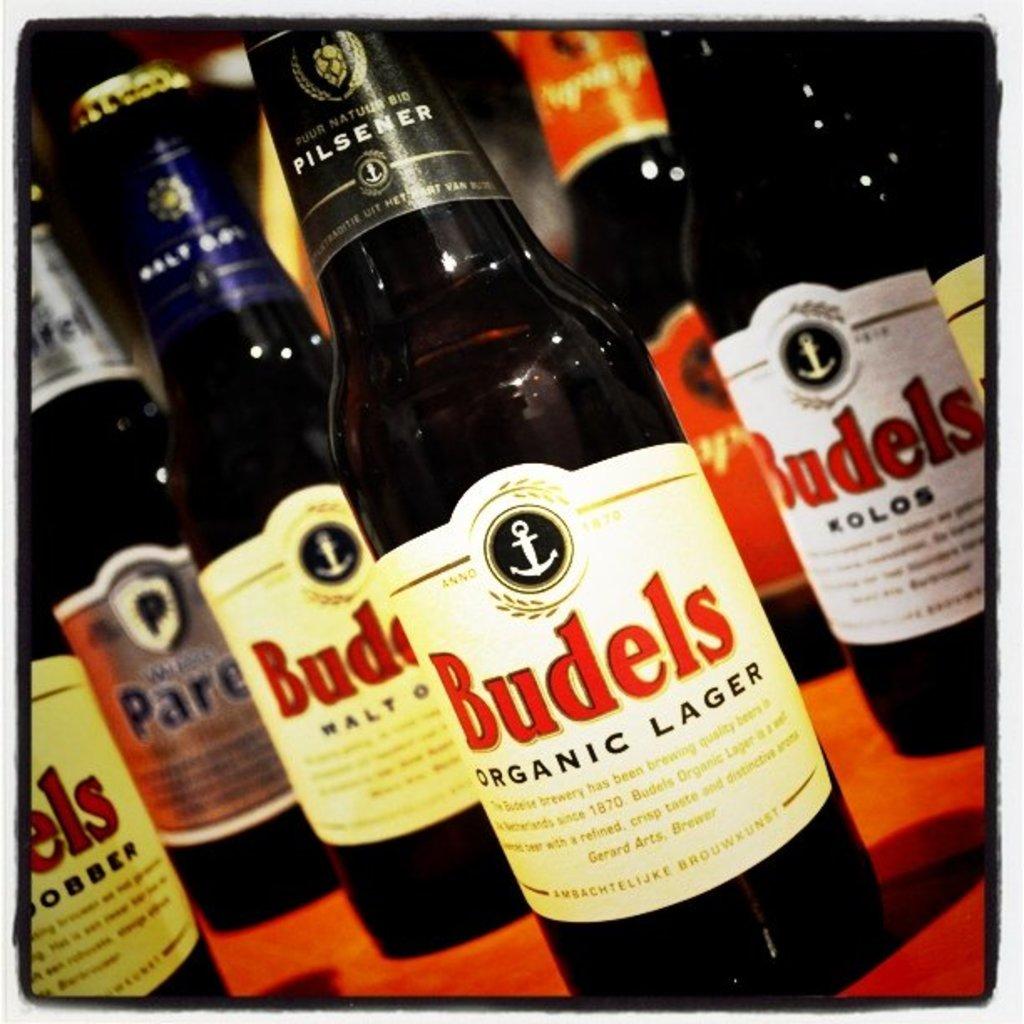Is the beer organic?
Keep it short and to the point. Yes. Whats the brand of beer inside these bottles?
Provide a short and direct response. Budels. 